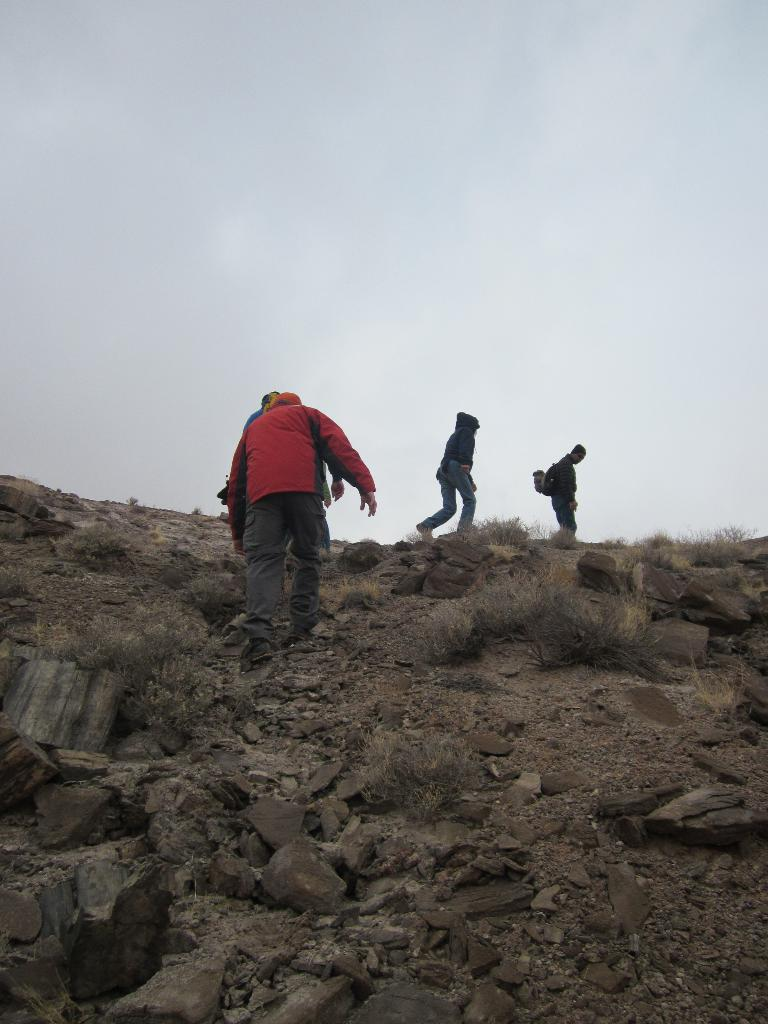What are the persons in the image doing? The persons in the image are walking on the ground. What can be seen on the right side of the image? There are stones on the right side of the image. What can be seen on the left side of the image? There are stones on the left side of the image. What is visible in the background of the image? There are clouds and the sky visible in the background of the image. Can you see an icicle hanging from the clouds in the image? There is no icicle visible in the image; only clouds and the sky are present in the background. 